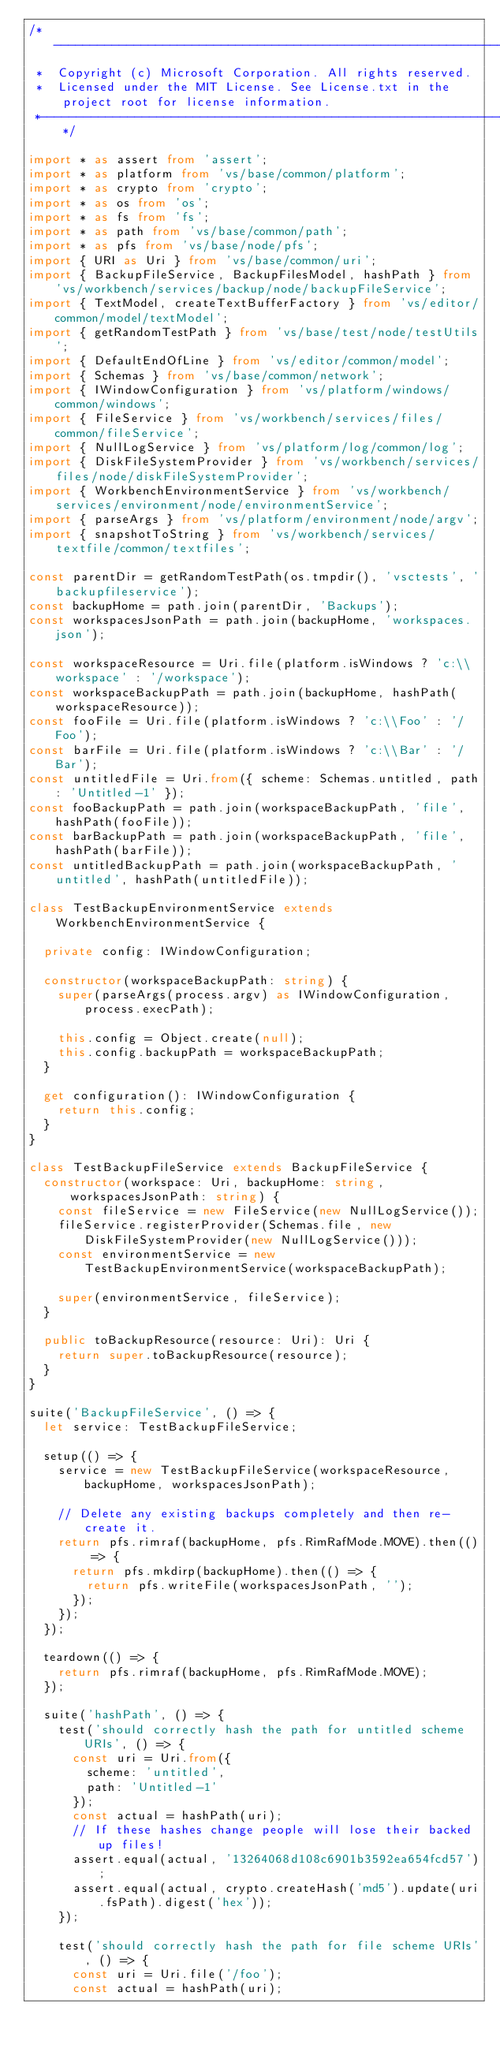Convert code to text. <code><loc_0><loc_0><loc_500><loc_500><_TypeScript_>/*---------------------------------------------------------------------------------------------
 *  Copyright (c) Microsoft Corporation. All rights reserved.
 *  Licensed under the MIT License. See License.txt in the project root for license information.
 *--------------------------------------------------------------------------------------------*/

import * as assert from 'assert';
import * as platform from 'vs/base/common/platform';
import * as crypto from 'crypto';
import * as os from 'os';
import * as fs from 'fs';
import * as path from 'vs/base/common/path';
import * as pfs from 'vs/base/node/pfs';
import { URI as Uri } from 'vs/base/common/uri';
import { BackupFileService, BackupFilesModel, hashPath } from 'vs/workbench/services/backup/node/backupFileService';
import { TextModel, createTextBufferFactory } from 'vs/editor/common/model/textModel';
import { getRandomTestPath } from 'vs/base/test/node/testUtils';
import { DefaultEndOfLine } from 'vs/editor/common/model';
import { Schemas } from 'vs/base/common/network';
import { IWindowConfiguration } from 'vs/platform/windows/common/windows';
import { FileService } from 'vs/workbench/services/files/common/fileService';
import { NullLogService } from 'vs/platform/log/common/log';
import { DiskFileSystemProvider } from 'vs/workbench/services/files/node/diskFileSystemProvider';
import { WorkbenchEnvironmentService } from 'vs/workbench/services/environment/node/environmentService';
import { parseArgs } from 'vs/platform/environment/node/argv';
import { snapshotToString } from 'vs/workbench/services/textfile/common/textfiles';

const parentDir = getRandomTestPath(os.tmpdir(), 'vsctests', 'backupfileservice');
const backupHome = path.join(parentDir, 'Backups');
const workspacesJsonPath = path.join(backupHome, 'workspaces.json');

const workspaceResource = Uri.file(platform.isWindows ? 'c:\\workspace' : '/workspace');
const workspaceBackupPath = path.join(backupHome, hashPath(workspaceResource));
const fooFile = Uri.file(platform.isWindows ? 'c:\\Foo' : '/Foo');
const barFile = Uri.file(platform.isWindows ? 'c:\\Bar' : '/Bar');
const untitledFile = Uri.from({ scheme: Schemas.untitled, path: 'Untitled-1' });
const fooBackupPath = path.join(workspaceBackupPath, 'file', hashPath(fooFile));
const barBackupPath = path.join(workspaceBackupPath, 'file', hashPath(barFile));
const untitledBackupPath = path.join(workspaceBackupPath, 'untitled', hashPath(untitledFile));

class TestBackupEnvironmentService extends WorkbenchEnvironmentService {

	private config: IWindowConfiguration;

	constructor(workspaceBackupPath: string) {
		super(parseArgs(process.argv) as IWindowConfiguration, process.execPath);

		this.config = Object.create(null);
		this.config.backupPath = workspaceBackupPath;
	}

	get configuration(): IWindowConfiguration {
		return this.config;
	}
}

class TestBackupFileService extends BackupFileService {
	constructor(workspace: Uri, backupHome: string, workspacesJsonPath: string) {
		const fileService = new FileService(new NullLogService());
		fileService.registerProvider(Schemas.file, new DiskFileSystemProvider(new NullLogService()));
		const environmentService = new TestBackupEnvironmentService(workspaceBackupPath);

		super(environmentService, fileService);
	}

	public toBackupResource(resource: Uri): Uri {
		return super.toBackupResource(resource);
	}
}

suite('BackupFileService', () => {
	let service: TestBackupFileService;

	setup(() => {
		service = new TestBackupFileService(workspaceResource, backupHome, workspacesJsonPath);

		// Delete any existing backups completely and then re-create it.
		return pfs.rimraf(backupHome, pfs.RimRafMode.MOVE).then(() => {
			return pfs.mkdirp(backupHome).then(() => {
				return pfs.writeFile(workspacesJsonPath, '');
			});
		});
	});

	teardown(() => {
		return pfs.rimraf(backupHome, pfs.RimRafMode.MOVE);
	});

	suite('hashPath', () => {
		test('should correctly hash the path for untitled scheme URIs', () => {
			const uri = Uri.from({
				scheme: 'untitled',
				path: 'Untitled-1'
			});
			const actual = hashPath(uri);
			// If these hashes change people will lose their backed up files!
			assert.equal(actual, '13264068d108c6901b3592ea654fcd57');
			assert.equal(actual, crypto.createHash('md5').update(uri.fsPath).digest('hex'));
		});

		test('should correctly hash the path for file scheme URIs', () => {
			const uri = Uri.file('/foo');
			const actual = hashPath(uri);</code> 